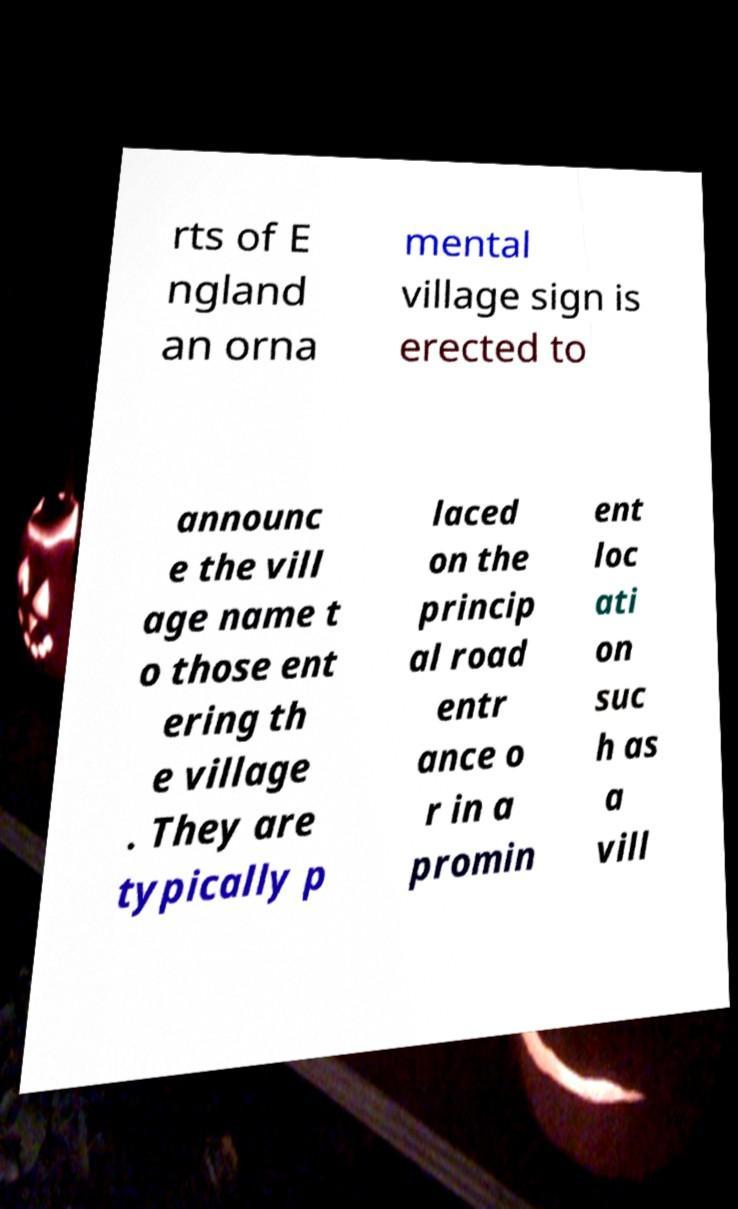For documentation purposes, I need the text within this image transcribed. Could you provide that? rts of E ngland an orna mental village sign is erected to announc e the vill age name t o those ent ering th e village . They are typically p laced on the princip al road entr ance o r in a promin ent loc ati on suc h as a vill 